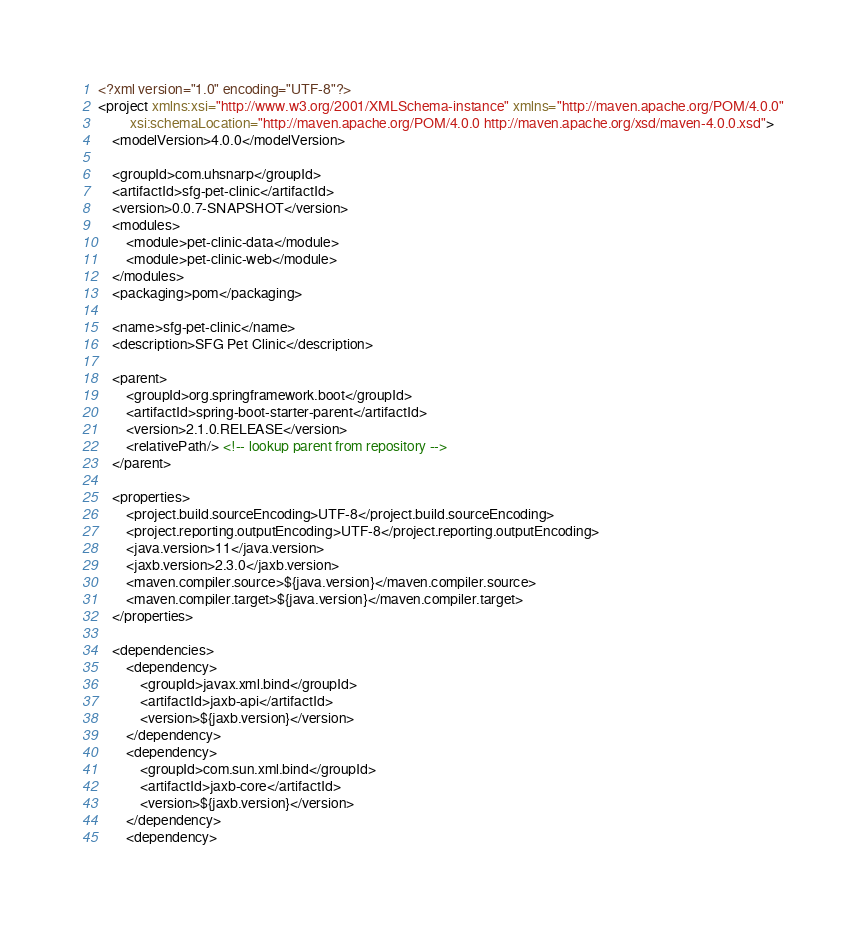Convert code to text. <code><loc_0><loc_0><loc_500><loc_500><_XML_><?xml version="1.0" encoding="UTF-8"?>
<project xmlns:xsi="http://www.w3.org/2001/XMLSchema-instance" xmlns="http://maven.apache.org/POM/4.0.0"
         xsi:schemaLocation="http://maven.apache.org/POM/4.0.0 http://maven.apache.org/xsd/maven-4.0.0.xsd">
    <modelVersion>4.0.0</modelVersion>

    <groupId>com.uhsnarp</groupId>
    <artifactId>sfg-pet-clinic</artifactId>
    <version>0.0.7-SNAPSHOT</version>
    <modules>
        <module>pet-clinic-data</module>
        <module>pet-clinic-web</module>
    </modules>
    <packaging>pom</packaging>

    <name>sfg-pet-clinic</name>
    <description>SFG Pet Clinic</description>

    <parent>
        <groupId>org.springframework.boot</groupId>
        <artifactId>spring-boot-starter-parent</artifactId>
        <version>2.1.0.RELEASE</version>
        <relativePath/> <!-- lookup parent from repository -->
    </parent>

    <properties>
        <project.build.sourceEncoding>UTF-8</project.build.sourceEncoding>
        <project.reporting.outputEncoding>UTF-8</project.reporting.outputEncoding>
        <java.version>11</java.version>
        <jaxb.version>2.3.0</jaxb.version>
        <maven.compiler.source>${java.version}</maven.compiler.source>
        <maven.compiler.target>${java.version}</maven.compiler.target>
    </properties>

    <dependencies>
        <dependency>
            <groupId>javax.xml.bind</groupId>
            <artifactId>jaxb-api</artifactId>
            <version>${jaxb.version}</version>
        </dependency>
        <dependency>
            <groupId>com.sun.xml.bind</groupId>
            <artifactId>jaxb-core</artifactId>
            <version>${jaxb.version}</version>
        </dependency>
        <dependency></code> 